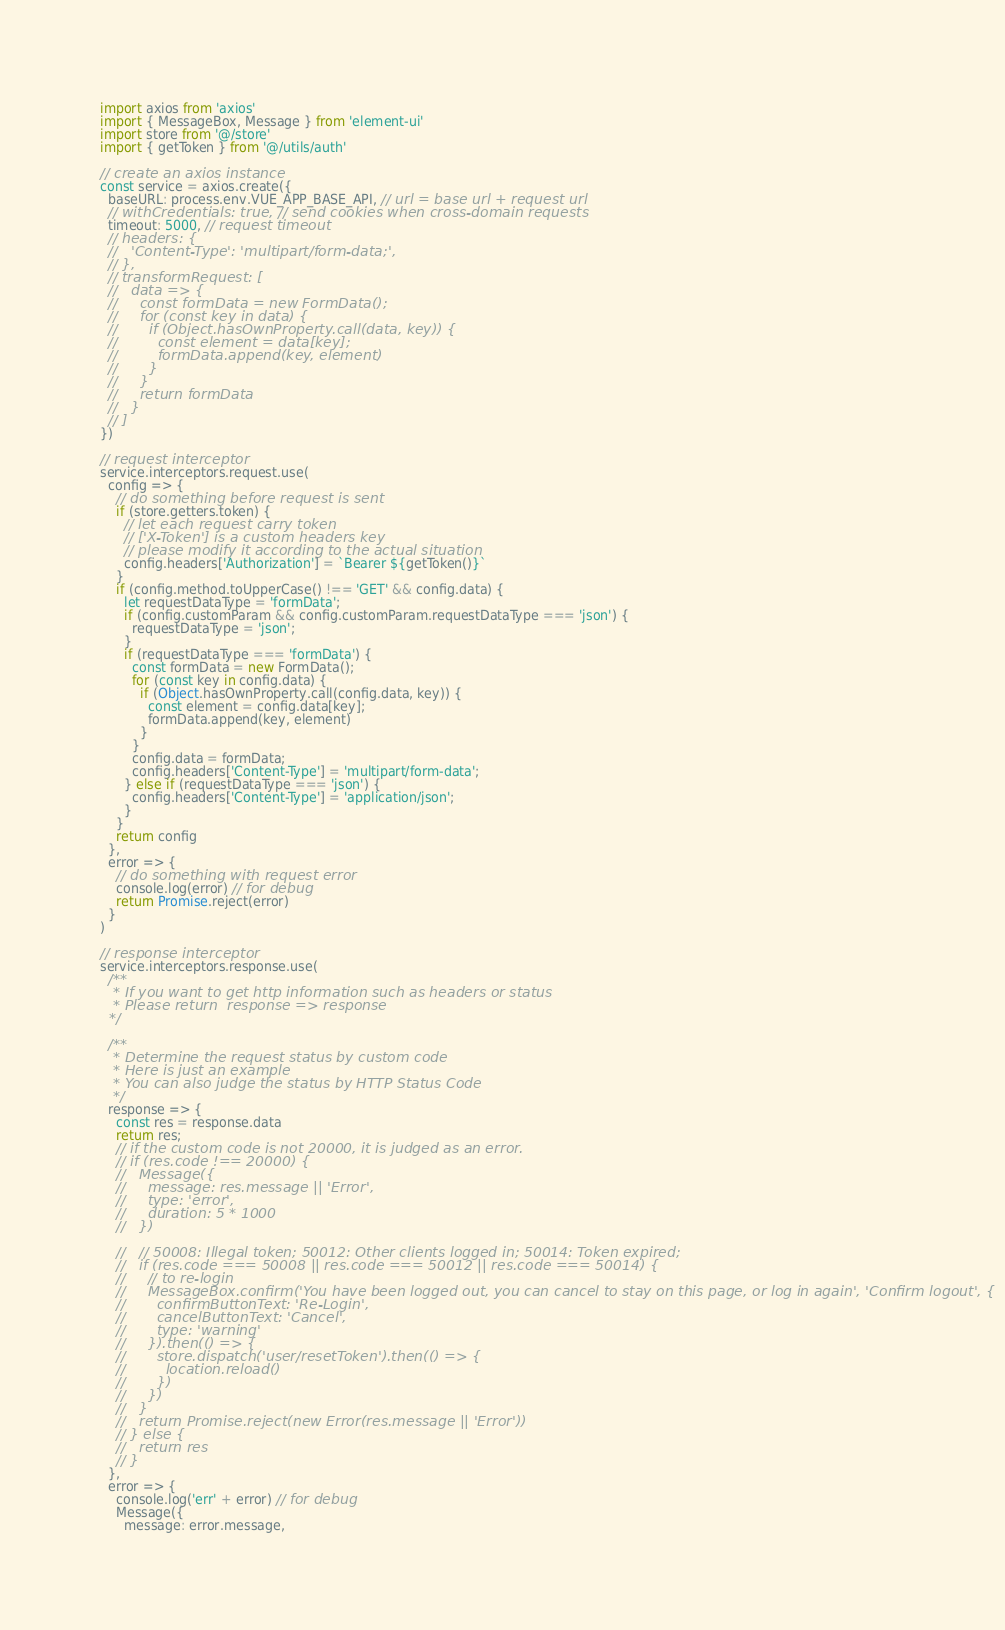<code> <loc_0><loc_0><loc_500><loc_500><_JavaScript_>import axios from 'axios'
import { MessageBox, Message } from 'element-ui'
import store from '@/store'
import { getToken } from '@/utils/auth'

// create an axios instance
const service = axios.create({
  baseURL: process.env.VUE_APP_BASE_API, // url = base url + request url
  // withCredentials: true, // send cookies when cross-domain requests
  timeout: 5000, // request timeout
  // headers: {
  //   'Content-Type': 'multipart/form-data;',
  // },
  // transformRequest: [
  //   data => {
  //     const formData = new FormData();
  //     for (const key in data) {
  //       if (Object.hasOwnProperty.call(data, key)) {
  //         const element = data[key];
  //         formData.append(key, element)
  //       }
  //     }
  //     return formData
  //   }
  // ]
})

// request interceptor
service.interceptors.request.use(
  config => {
    // do something before request is sent
    if (store.getters.token) {
      // let each request carry token
      // ['X-Token'] is a custom headers key
      // please modify it according to the actual situation
      config.headers['Authorization'] = `Bearer ${getToken()}`
    }
    if (config.method.toUpperCase() !== 'GET' && config.data) {
      let requestDataType = 'formData';
      if (config.customParam && config.customParam.requestDataType === 'json') {
        requestDataType = 'json';
      }
      if (requestDataType === 'formData') {
        const formData = new FormData();
        for (const key in config.data) {
          if (Object.hasOwnProperty.call(config.data, key)) {
            const element = config.data[key];
            formData.append(key, element)
          }
        }
        config.data = formData;
        config.headers['Content-Type'] = 'multipart/form-data';
      } else if (requestDataType === 'json') {
        config.headers['Content-Type'] = 'application/json';
      }
    }
    return config
  },
  error => {
    // do something with request error
    console.log(error) // for debug
    return Promise.reject(error)
  }
)

// response interceptor
service.interceptors.response.use(
  /**
   * If you want to get http information such as headers or status
   * Please return  response => response
  */

  /**
   * Determine the request status by custom code
   * Here is just an example
   * You can also judge the status by HTTP Status Code
   */
  response => {
    const res = response.data
    return res;
    // if the custom code is not 20000, it is judged as an error.
    // if (res.code !== 20000) {
    //   Message({
    //     message: res.message || 'Error',
    //     type: 'error',
    //     duration: 5 * 1000
    //   })

    //   // 50008: Illegal token; 50012: Other clients logged in; 50014: Token expired;
    //   if (res.code === 50008 || res.code === 50012 || res.code === 50014) {
    //     // to re-login
    //     MessageBox.confirm('You have been logged out, you can cancel to stay on this page, or log in again', 'Confirm logout', {
    //       confirmButtonText: 'Re-Login',
    //       cancelButtonText: 'Cancel',
    //       type: 'warning'
    //     }).then(() => {
    //       store.dispatch('user/resetToken').then(() => {
    //         location.reload()
    //       })
    //     })
    //   }
    //   return Promise.reject(new Error(res.message || 'Error'))
    // } else {
    //   return res
    // }
  },
  error => {
    console.log('err' + error) // for debug
    Message({
      message: error.message,</code> 